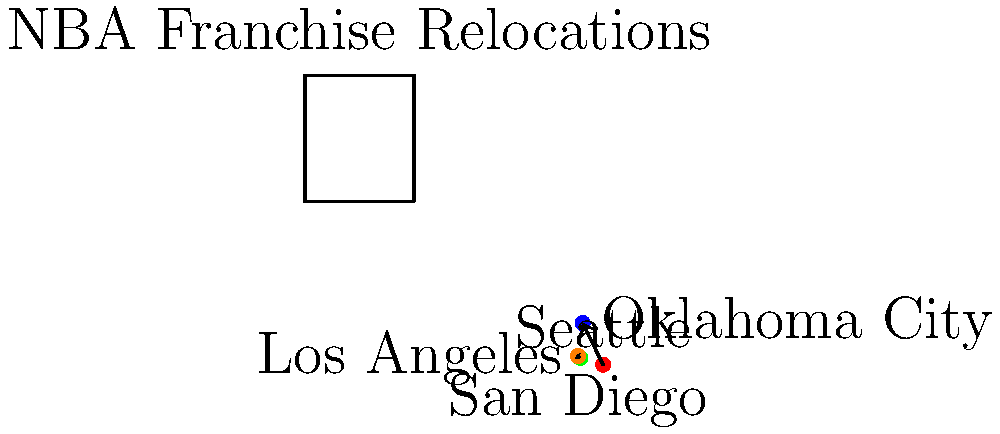Based on the geographic coordinate system shown, which NBA franchise relocation covered the greatest distance, and approximately how many miles did the team move? To determine which NBA franchise relocation covered the greatest distance, we need to compare the two relocations shown on the map:

1. Seattle SuperSonics to Oklahoma City Thunder
2. San Diego Clippers to Los Angeles Clippers

Step 1: Calculate the distance for Seattle to Oklahoma City
- Seattle coordinates: (47.6062, -122.3321)
- Oklahoma City coordinates: (35.4676, -97.5164)
- Using the Haversine formula for calculating distance on a sphere:
  $d = 2R \arcsin(\sqrt{\sin^2(\frac{\Delta\phi}{2}) + \cos\phi_1\cos\phi_2\sin^2(\frac{\Delta\lambda}{2})})$
  Where R is Earth's radius (≈ 3,959 miles), φ is latitude, and λ is longitude
- The resulting distance is approximately 1,752 miles

Step 2: Calculate the distance for San Diego to Los Angeles
- San Diego coordinates: (32.7157, -117.1611)
- Los Angeles coordinates: (34.0522, -118.2437)
- Using the same Haversine formula
- The resulting distance is approximately 112 miles

Step 3: Compare the distances
- Seattle to Oklahoma City: 1,752 miles
- San Diego to Los Angeles: 112 miles

The Seattle SuperSonics to Oklahoma City Thunder relocation covered a significantly greater distance.
Answer: Seattle SuperSonics to Oklahoma City Thunder, approximately 1,752 miles 